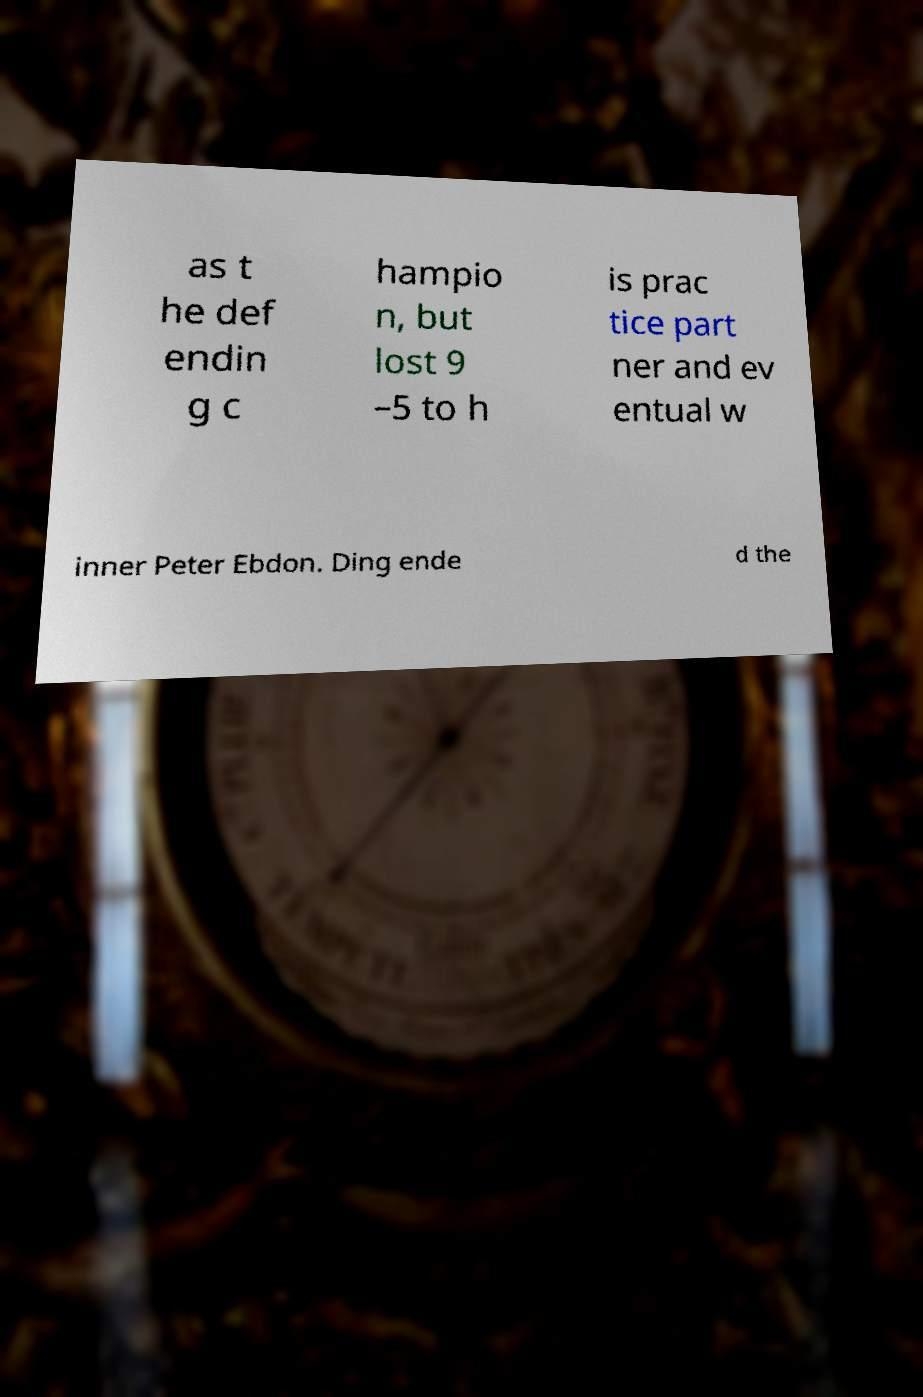Please identify and transcribe the text found in this image. as t he def endin g c hampio n, but lost 9 –5 to h is prac tice part ner and ev entual w inner Peter Ebdon. Ding ende d the 